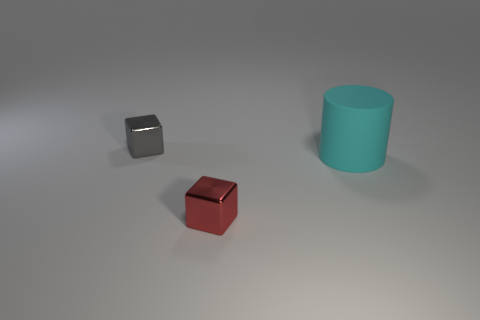The rubber thing is what color?
Your answer should be compact. Cyan. How many other objects are there of the same material as the big cyan cylinder?
Your answer should be compact. 0. What number of yellow things are big matte cylinders or metallic spheres?
Provide a succinct answer. 0. There is a gray metal thing that is left of the tiny red thing; is its shape the same as the object that is in front of the matte thing?
Ensure brevity in your answer.  Yes. There is a large object; is it the same color as the block in front of the big cyan rubber object?
Provide a short and direct response. No. Do the tiny shiny cube that is behind the cyan object and the big thing have the same color?
Keep it short and to the point. No. How many things are yellow spheres or objects to the right of the gray metallic object?
Offer a very short reply. 2. There is a object that is both in front of the small gray cube and behind the red cube; what material is it made of?
Offer a very short reply. Rubber. What material is the small red thing left of the cyan rubber cylinder?
Give a very brief answer. Metal. What is the color of the other tiny cube that is the same material as the gray cube?
Make the answer very short. Red. 